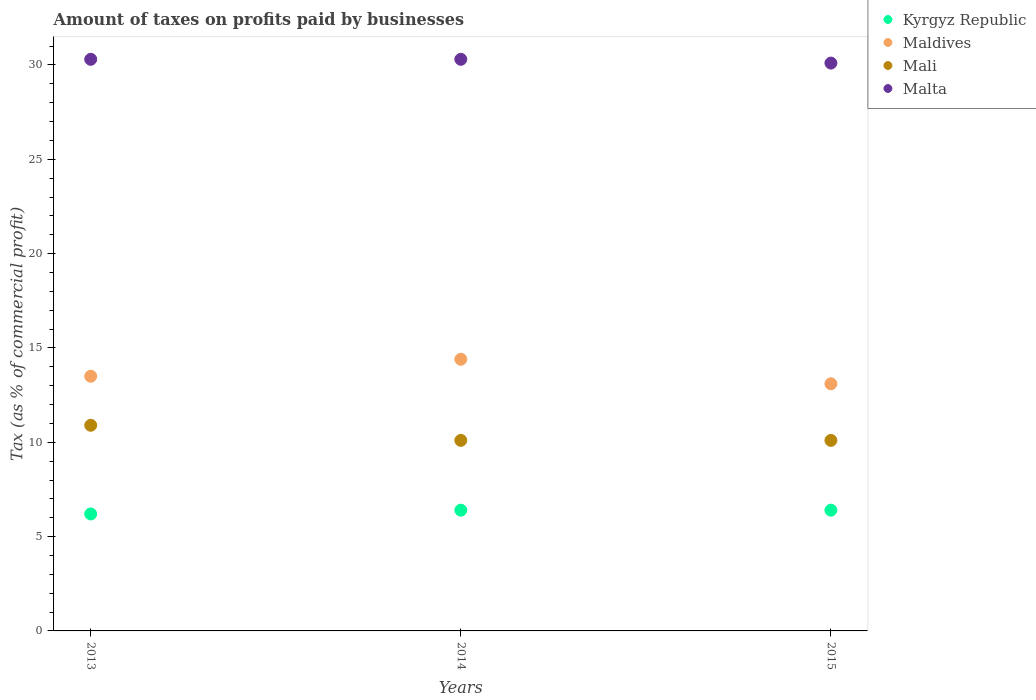Is the number of dotlines equal to the number of legend labels?
Offer a terse response. Yes. Across all years, what is the maximum percentage of taxes paid by businesses in Mali?
Ensure brevity in your answer.  10.9. Across all years, what is the minimum percentage of taxes paid by businesses in Mali?
Offer a very short reply. 10.1. In which year was the percentage of taxes paid by businesses in Maldives maximum?
Ensure brevity in your answer.  2014. In which year was the percentage of taxes paid by businesses in Maldives minimum?
Offer a terse response. 2015. What is the total percentage of taxes paid by businesses in Malta in the graph?
Keep it short and to the point. 90.7. What is the difference between the percentage of taxes paid by businesses in Maldives in 2013 and that in 2014?
Provide a succinct answer. -0.9. What is the difference between the percentage of taxes paid by businesses in Maldives in 2015 and the percentage of taxes paid by businesses in Kyrgyz Republic in 2013?
Your response must be concise. 6.9. What is the average percentage of taxes paid by businesses in Mali per year?
Offer a terse response. 10.37. In the year 2014, what is the difference between the percentage of taxes paid by businesses in Malta and percentage of taxes paid by businesses in Kyrgyz Republic?
Give a very brief answer. 23.9. In how many years, is the percentage of taxes paid by businesses in Kyrgyz Republic greater than 30 %?
Keep it short and to the point. 0. What is the ratio of the percentage of taxes paid by businesses in Kyrgyz Republic in 2013 to that in 2014?
Your answer should be very brief. 0.97. Is the percentage of taxes paid by businesses in Maldives in 2014 less than that in 2015?
Your response must be concise. No. What is the difference between the highest and the lowest percentage of taxes paid by businesses in Malta?
Provide a short and direct response. 0.2. In how many years, is the percentage of taxes paid by businesses in Kyrgyz Republic greater than the average percentage of taxes paid by businesses in Kyrgyz Republic taken over all years?
Make the answer very short. 2. Does the percentage of taxes paid by businesses in Kyrgyz Republic monotonically increase over the years?
Offer a very short reply. No. What is the difference between two consecutive major ticks on the Y-axis?
Give a very brief answer. 5. Are the values on the major ticks of Y-axis written in scientific E-notation?
Provide a succinct answer. No. How are the legend labels stacked?
Offer a very short reply. Vertical. What is the title of the graph?
Offer a terse response. Amount of taxes on profits paid by businesses. What is the label or title of the Y-axis?
Your answer should be compact. Tax (as % of commercial profit). What is the Tax (as % of commercial profit) of Malta in 2013?
Give a very brief answer. 30.3. What is the Tax (as % of commercial profit) in Maldives in 2014?
Make the answer very short. 14.4. What is the Tax (as % of commercial profit) in Malta in 2014?
Offer a terse response. 30.3. What is the Tax (as % of commercial profit) in Maldives in 2015?
Offer a very short reply. 13.1. What is the Tax (as % of commercial profit) of Malta in 2015?
Give a very brief answer. 30.1. Across all years, what is the maximum Tax (as % of commercial profit) of Maldives?
Ensure brevity in your answer.  14.4. Across all years, what is the maximum Tax (as % of commercial profit) in Mali?
Offer a very short reply. 10.9. Across all years, what is the maximum Tax (as % of commercial profit) in Malta?
Provide a succinct answer. 30.3. Across all years, what is the minimum Tax (as % of commercial profit) of Mali?
Ensure brevity in your answer.  10.1. Across all years, what is the minimum Tax (as % of commercial profit) of Malta?
Provide a short and direct response. 30.1. What is the total Tax (as % of commercial profit) of Kyrgyz Republic in the graph?
Make the answer very short. 19. What is the total Tax (as % of commercial profit) in Maldives in the graph?
Provide a short and direct response. 41. What is the total Tax (as % of commercial profit) of Mali in the graph?
Offer a very short reply. 31.1. What is the total Tax (as % of commercial profit) of Malta in the graph?
Your answer should be compact. 90.7. What is the difference between the Tax (as % of commercial profit) in Malta in 2013 and that in 2014?
Offer a terse response. 0. What is the difference between the Tax (as % of commercial profit) in Mali in 2013 and that in 2015?
Provide a short and direct response. 0.8. What is the difference between the Tax (as % of commercial profit) of Maldives in 2014 and that in 2015?
Offer a terse response. 1.3. What is the difference between the Tax (as % of commercial profit) in Malta in 2014 and that in 2015?
Provide a succinct answer. 0.2. What is the difference between the Tax (as % of commercial profit) in Kyrgyz Republic in 2013 and the Tax (as % of commercial profit) in Maldives in 2014?
Offer a very short reply. -8.2. What is the difference between the Tax (as % of commercial profit) in Kyrgyz Republic in 2013 and the Tax (as % of commercial profit) in Malta in 2014?
Provide a succinct answer. -24.1. What is the difference between the Tax (as % of commercial profit) in Maldives in 2013 and the Tax (as % of commercial profit) in Malta in 2014?
Your response must be concise. -16.8. What is the difference between the Tax (as % of commercial profit) of Mali in 2013 and the Tax (as % of commercial profit) of Malta in 2014?
Your response must be concise. -19.4. What is the difference between the Tax (as % of commercial profit) in Kyrgyz Republic in 2013 and the Tax (as % of commercial profit) in Maldives in 2015?
Your response must be concise. -6.9. What is the difference between the Tax (as % of commercial profit) in Kyrgyz Republic in 2013 and the Tax (as % of commercial profit) in Mali in 2015?
Give a very brief answer. -3.9. What is the difference between the Tax (as % of commercial profit) of Kyrgyz Republic in 2013 and the Tax (as % of commercial profit) of Malta in 2015?
Give a very brief answer. -23.9. What is the difference between the Tax (as % of commercial profit) in Maldives in 2013 and the Tax (as % of commercial profit) in Malta in 2015?
Offer a terse response. -16.6. What is the difference between the Tax (as % of commercial profit) in Mali in 2013 and the Tax (as % of commercial profit) in Malta in 2015?
Your answer should be very brief. -19.2. What is the difference between the Tax (as % of commercial profit) of Kyrgyz Republic in 2014 and the Tax (as % of commercial profit) of Mali in 2015?
Make the answer very short. -3.7. What is the difference between the Tax (as % of commercial profit) of Kyrgyz Republic in 2014 and the Tax (as % of commercial profit) of Malta in 2015?
Ensure brevity in your answer.  -23.7. What is the difference between the Tax (as % of commercial profit) in Maldives in 2014 and the Tax (as % of commercial profit) in Malta in 2015?
Keep it short and to the point. -15.7. What is the average Tax (as % of commercial profit) of Kyrgyz Republic per year?
Provide a short and direct response. 6.33. What is the average Tax (as % of commercial profit) of Maldives per year?
Offer a terse response. 13.67. What is the average Tax (as % of commercial profit) in Mali per year?
Offer a very short reply. 10.37. What is the average Tax (as % of commercial profit) of Malta per year?
Ensure brevity in your answer.  30.23. In the year 2013, what is the difference between the Tax (as % of commercial profit) of Kyrgyz Republic and Tax (as % of commercial profit) of Maldives?
Your answer should be compact. -7.3. In the year 2013, what is the difference between the Tax (as % of commercial profit) of Kyrgyz Republic and Tax (as % of commercial profit) of Mali?
Ensure brevity in your answer.  -4.7. In the year 2013, what is the difference between the Tax (as % of commercial profit) of Kyrgyz Republic and Tax (as % of commercial profit) of Malta?
Provide a short and direct response. -24.1. In the year 2013, what is the difference between the Tax (as % of commercial profit) in Maldives and Tax (as % of commercial profit) in Mali?
Ensure brevity in your answer.  2.6. In the year 2013, what is the difference between the Tax (as % of commercial profit) in Maldives and Tax (as % of commercial profit) in Malta?
Provide a short and direct response. -16.8. In the year 2013, what is the difference between the Tax (as % of commercial profit) of Mali and Tax (as % of commercial profit) of Malta?
Provide a succinct answer. -19.4. In the year 2014, what is the difference between the Tax (as % of commercial profit) of Kyrgyz Republic and Tax (as % of commercial profit) of Mali?
Offer a terse response. -3.7. In the year 2014, what is the difference between the Tax (as % of commercial profit) in Kyrgyz Republic and Tax (as % of commercial profit) in Malta?
Give a very brief answer. -23.9. In the year 2014, what is the difference between the Tax (as % of commercial profit) of Maldives and Tax (as % of commercial profit) of Malta?
Provide a short and direct response. -15.9. In the year 2014, what is the difference between the Tax (as % of commercial profit) in Mali and Tax (as % of commercial profit) in Malta?
Offer a terse response. -20.2. In the year 2015, what is the difference between the Tax (as % of commercial profit) of Kyrgyz Republic and Tax (as % of commercial profit) of Maldives?
Provide a short and direct response. -6.7. In the year 2015, what is the difference between the Tax (as % of commercial profit) in Kyrgyz Republic and Tax (as % of commercial profit) in Mali?
Provide a short and direct response. -3.7. In the year 2015, what is the difference between the Tax (as % of commercial profit) in Kyrgyz Republic and Tax (as % of commercial profit) in Malta?
Offer a terse response. -23.7. What is the ratio of the Tax (as % of commercial profit) in Kyrgyz Republic in 2013 to that in 2014?
Offer a very short reply. 0.97. What is the ratio of the Tax (as % of commercial profit) of Mali in 2013 to that in 2014?
Offer a very short reply. 1.08. What is the ratio of the Tax (as % of commercial profit) of Kyrgyz Republic in 2013 to that in 2015?
Provide a short and direct response. 0.97. What is the ratio of the Tax (as % of commercial profit) of Maldives in 2013 to that in 2015?
Provide a short and direct response. 1.03. What is the ratio of the Tax (as % of commercial profit) in Mali in 2013 to that in 2015?
Your response must be concise. 1.08. What is the ratio of the Tax (as % of commercial profit) in Malta in 2013 to that in 2015?
Offer a terse response. 1.01. What is the ratio of the Tax (as % of commercial profit) of Kyrgyz Republic in 2014 to that in 2015?
Provide a succinct answer. 1. What is the ratio of the Tax (as % of commercial profit) of Maldives in 2014 to that in 2015?
Give a very brief answer. 1.1. What is the ratio of the Tax (as % of commercial profit) of Malta in 2014 to that in 2015?
Provide a short and direct response. 1.01. What is the difference between the highest and the second highest Tax (as % of commercial profit) in Maldives?
Give a very brief answer. 0.9. What is the difference between the highest and the second highest Tax (as % of commercial profit) in Malta?
Provide a short and direct response. 0. What is the difference between the highest and the lowest Tax (as % of commercial profit) of Malta?
Your answer should be very brief. 0.2. 